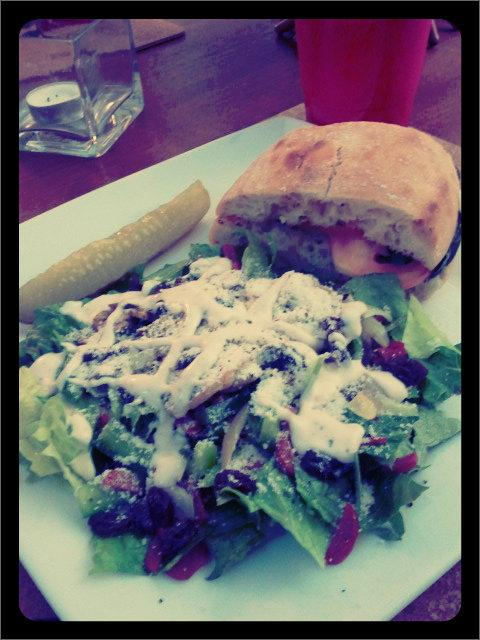What shape is the pickle cut in? Please explain your reasoning. spear. The pickle shape is long. 